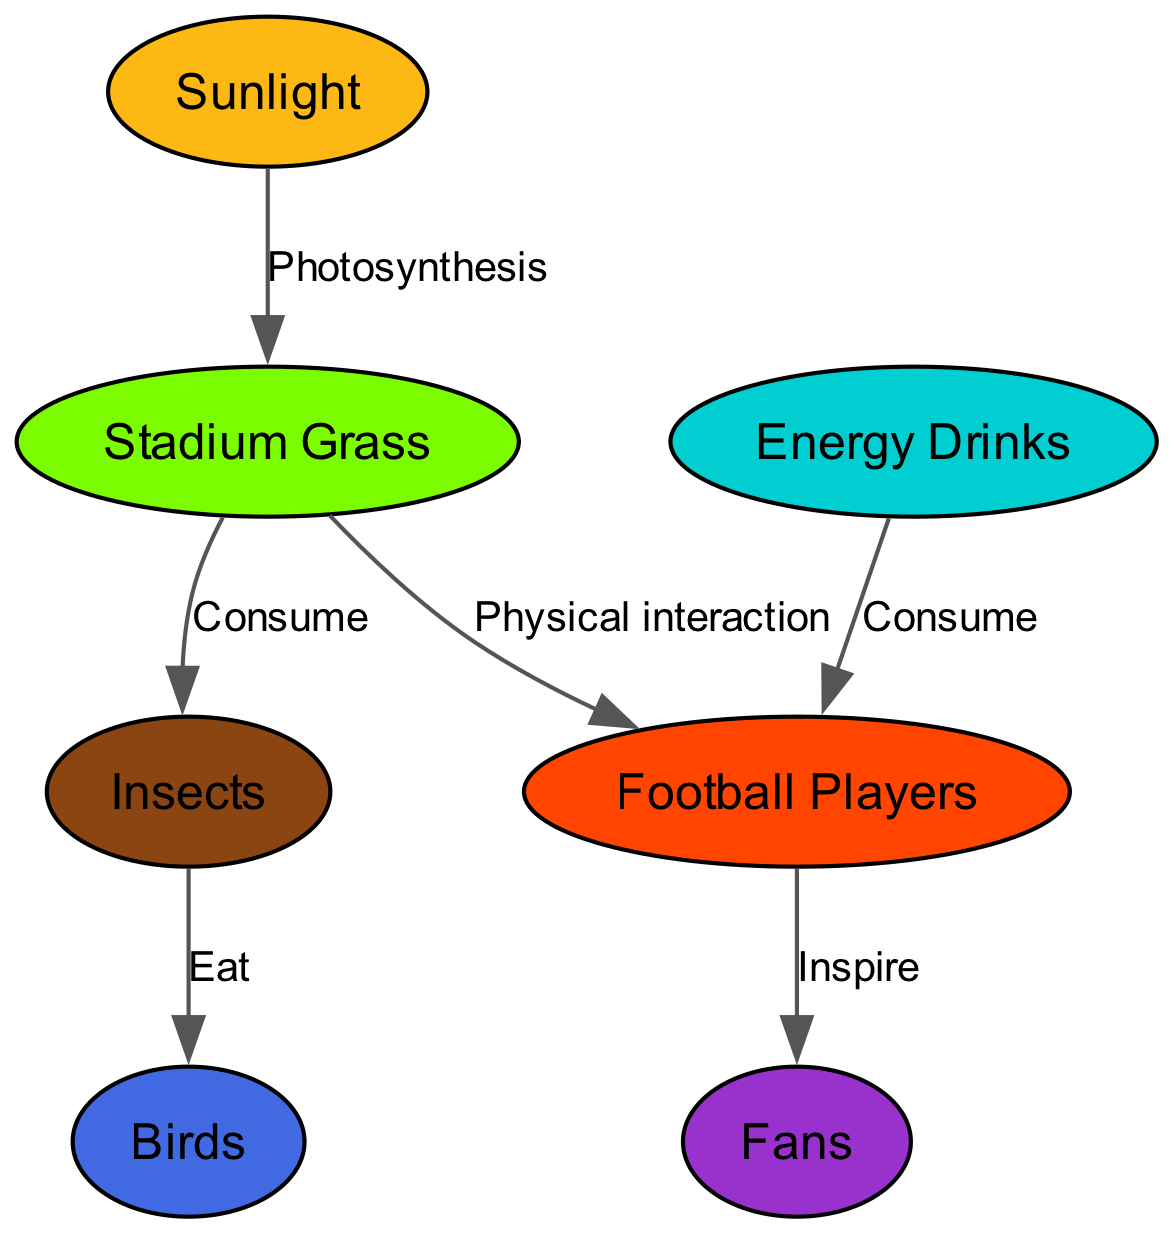What is the primary source of energy for the grass in the stadium? The diagram indicates that sunlight is the primary energy source for grass as it shows a direct relationship labeled "Photosynthesis."
Answer: Sunlight How many connections are there from grass to other elements? The diagram shows that grass has connections to three other elements: insects, players, and birds. Therefore, the total number of connections from grass is three.
Answer: 3 Which element inspires the fans? According to the diagram, the players are the ones who inspire the fans, as indicated by the connection labeled "Inspire."
Answer: Players What do insects consume? The diagram specifically shows that insects consume the grass, which is indicated by the relationship labeled "Consume."
Answer: Grass How do players receive energy besides grass? The diagram indicates that players receive energy not only from grass but also by consuming energy drinks, as shown by the labeled connection "Consume."
Answer: Energy Drinks What connects birds to the food chain? The diagram shows that birds are connected to the food chain through their eating of insects, as indicated by the relationship labeled "Eat."
Answer: Insects Which element has no outgoing connections? The insects do not have any outgoing connections in the diagram, as their only connection is to the birds.
Answer: Insects How many total elements are represented in the diagram? The diagram includes a total of seven different elements: sunlight, grass, insects, birds, players, fans, and energy drinks. Counting all of these elements gives a total of seven.
Answer: 7 What is the role of grass in the ecosystem? The grass has multiple roles in the ecosystem, acting as a source of energy for insects and players, as shown by the labeled connections. Thus, grass plays a role in energy flow to both insects and players.
Answer: Energy Source 